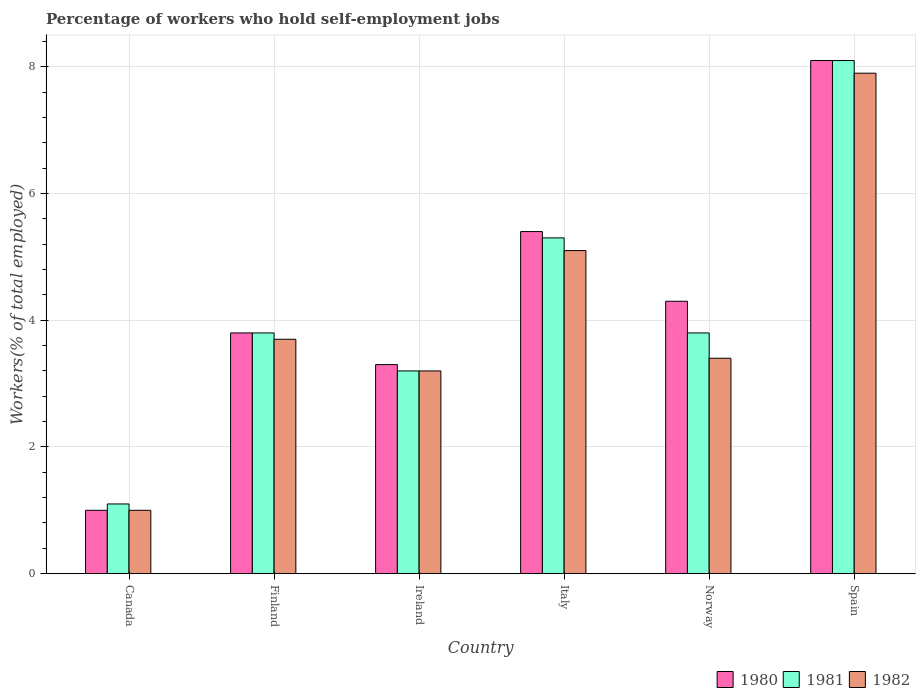How many different coloured bars are there?
Your answer should be compact. 3. Are the number of bars on each tick of the X-axis equal?
Your response must be concise. Yes. How many bars are there on the 2nd tick from the right?
Your answer should be compact. 3. What is the label of the 2nd group of bars from the left?
Your response must be concise. Finland. In how many cases, is the number of bars for a given country not equal to the number of legend labels?
Offer a terse response. 0. Across all countries, what is the maximum percentage of self-employed workers in 1982?
Ensure brevity in your answer.  7.9. Across all countries, what is the minimum percentage of self-employed workers in 1981?
Your answer should be compact. 1.1. In which country was the percentage of self-employed workers in 1980 maximum?
Make the answer very short. Spain. What is the total percentage of self-employed workers in 1982 in the graph?
Your answer should be compact. 24.3. What is the difference between the percentage of self-employed workers in 1981 in Canada and that in Spain?
Your answer should be very brief. -7. What is the difference between the percentage of self-employed workers in 1981 in Ireland and the percentage of self-employed workers in 1982 in Finland?
Your answer should be very brief. -0.5. What is the average percentage of self-employed workers in 1981 per country?
Your answer should be very brief. 4.22. What is the difference between the percentage of self-employed workers of/in 1981 and percentage of self-employed workers of/in 1980 in Ireland?
Keep it short and to the point. -0.1. In how many countries, is the percentage of self-employed workers in 1981 greater than 4 %?
Provide a succinct answer. 2. What is the ratio of the percentage of self-employed workers in 1980 in Italy to that in Spain?
Provide a succinct answer. 0.67. Is the percentage of self-employed workers in 1982 in Finland less than that in Norway?
Your answer should be very brief. No. What is the difference between the highest and the second highest percentage of self-employed workers in 1980?
Offer a terse response. 3.8. What is the difference between the highest and the lowest percentage of self-employed workers in 1982?
Provide a succinct answer. 6.9. In how many countries, is the percentage of self-employed workers in 1981 greater than the average percentage of self-employed workers in 1981 taken over all countries?
Ensure brevity in your answer.  2. What does the 1st bar from the right in Finland represents?
Provide a short and direct response. 1982. How many bars are there?
Give a very brief answer. 18. Are all the bars in the graph horizontal?
Provide a succinct answer. No. How many countries are there in the graph?
Your answer should be compact. 6. What is the difference between two consecutive major ticks on the Y-axis?
Your answer should be compact. 2. Does the graph contain any zero values?
Your answer should be compact. No. What is the title of the graph?
Offer a very short reply. Percentage of workers who hold self-employment jobs. Does "1995" appear as one of the legend labels in the graph?
Keep it short and to the point. No. What is the label or title of the Y-axis?
Provide a short and direct response. Workers(% of total employed). What is the Workers(% of total employed) in 1980 in Canada?
Ensure brevity in your answer.  1. What is the Workers(% of total employed) of 1981 in Canada?
Give a very brief answer. 1.1. What is the Workers(% of total employed) in 1980 in Finland?
Provide a short and direct response. 3.8. What is the Workers(% of total employed) in 1981 in Finland?
Give a very brief answer. 3.8. What is the Workers(% of total employed) in 1982 in Finland?
Your response must be concise. 3.7. What is the Workers(% of total employed) of 1980 in Ireland?
Ensure brevity in your answer.  3.3. What is the Workers(% of total employed) of 1981 in Ireland?
Provide a succinct answer. 3.2. What is the Workers(% of total employed) of 1982 in Ireland?
Provide a succinct answer. 3.2. What is the Workers(% of total employed) of 1980 in Italy?
Ensure brevity in your answer.  5.4. What is the Workers(% of total employed) of 1981 in Italy?
Your answer should be compact. 5.3. What is the Workers(% of total employed) in 1982 in Italy?
Provide a short and direct response. 5.1. What is the Workers(% of total employed) in 1980 in Norway?
Your response must be concise. 4.3. What is the Workers(% of total employed) in 1981 in Norway?
Make the answer very short. 3.8. What is the Workers(% of total employed) of 1982 in Norway?
Ensure brevity in your answer.  3.4. What is the Workers(% of total employed) of 1980 in Spain?
Provide a succinct answer. 8.1. What is the Workers(% of total employed) of 1981 in Spain?
Your answer should be compact. 8.1. What is the Workers(% of total employed) in 1982 in Spain?
Provide a succinct answer. 7.9. Across all countries, what is the maximum Workers(% of total employed) of 1980?
Provide a succinct answer. 8.1. Across all countries, what is the maximum Workers(% of total employed) in 1981?
Your answer should be very brief. 8.1. Across all countries, what is the maximum Workers(% of total employed) in 1982?
Provide a succinct answer. 7.9. Across all countries, what is the minimum Workers(% of total employed) of 1980?
Offer a very short reply. 1. Across all countries, what is the minimum Workers(% of total employed) of 1981?
Keep it short and to the point. 1.1. What is the total Workers(% of total employed) of 1980 in the graph?
Provide a short and direct response. 25.9. What is the total Workers(% of total employed) in 1981 in the graph?
Offer a terse response. 25.3. What is the total Workers(% of total employed) in 1982 in the graph?
Keep it short and to the point. 24.3. What is the difference between the Workers(% of total employed) in 1980 in Canada and that in Finland?
Make the answer very short. -2.8. What is the difference between the Workers(% of total employed) of 1982 in Canada and that in Finland?
Your answer should be compact. -2.7. What is the difference between the Workers(% of total employed) of 1980 in Canada and that in Ireland?
Offer a terse response. -2.3. What is the difference between the Workers(% of total employed) of 1981 in Canada and that in Ireland?
Your answer should be very brief. -2.1. What is the difference between the Workers(% of total employed) of 1982 in Canada and that in Ireland?
Ensure brevity in your answer.  -2.2. What is the difference between the Workers(% of total employed) of 1981 in Canada and that in Spain?
Make the answer very short. -7. What is the difference between the Workers(% of total employed) of 1982 in Canada and that in Spain?
Keep it short and to the point. -6.9. What is the difference between the Workers(% of total employed) in 1980 in Finland and that in Ireland?
Provide a succinct answer. 0.5. What is the difference between the Workers(% of total employed) in 1981 in Finland and that in Ireland?
Offer a terse response. 0.6. What is the difference between the Workers(% of total employed) in 1981 in Finland and that in Italy?
Make the answer very short. -1.5. What is the difference between the Workers(% of total employed) of 1982 in Finland and that in Italy?
Give a very brief answer. -1.4. What is the difference between the Workers(% of total employed) of 1981 in Finland and that in Norway?
Your answer should be compact. 0. What is the difference between the Workers(% of total employed) in 1980 in Finland and that in Spain?
Provide a succinct answer. -4.3. What is the difference between the Workers(% of total employed) of 1981 in Finland and that in Spain?
Provide a succinct answer. -4.3. What is the difference between the Workers(% of total employed) in 1980 in Ireland and that in Italy?
Give a very brief answer. -2.1. What is the difference between the Workers(% of total employed) of 1981 in Ireland and that in Norway?
Provide a short and direct response. -0.6. What is the difference between the Workers(% of total employed) of 1980 in Ireland and that in Spain?
Make the answer very short. -4.8. What is the difference between the Workers(% of total employed) in 1981 in Ireland and that in Spain?
Your answer should be very brief. -4.9. What is the difference between the Workers(% of total employed) of 1982 in Ireland and that in Spain?
Make the answer very short. -4.7. What is the difference between the Workers(% of total employed) in 1980 in Italy and that in Norway?
Your response must be concise. 1.1. What is the difference between the Workers(% of total employed) in 1981 in Italy and that in Norway?
Your answer should be very brief. 1.5. What is the difference between the Workers(% of total employed) in 1982 in Italy and that in Norway?
Provide a succinct answer. 1.7. What is the difference between the Workers(% of total employed) of 1980 in Italy and that in Spain?
Offer a terse response. -2.7. What is the difference between the Workers(% of total employed) in 1982 in Italy and that in Spain?
Make the answer very short. -2.8. What is the difference between the Workers(% of total employed) in 1982 in Norway and that in Spain?
Provide a short and direct response. -4.5. What is the difference between the Workers(% of total employed) of 1980 in Canada and the Workers(% of total employed) of 1982 in Finland?
Your answer should be very brief. -2.7. What is the difference between the Workers(% of total employed) in 1981 in Canada and the Workers(% of total employed) in 1982 in Finland?
Provide a succinct answer. -2.6. What is the difference between the Workers(% of total employed) of 1980 in Canada and the Workers(% of total employed) of 1982 in Ireland?
Make the answer very short. -2.2. What is the difference between the Workers(% of total employed) in 1980 in Canada and the Workers(% of total employed) in 1981 in Italy?
Make the answer very short. -4.3. What is the difference between the Workers(% of total employed) of 1981 in Canada and the Workers(% of total employed) of 1982 in Italy?
Your answer should be compact. -4. What is the difference between the Workers(% of total employed) in 1980 in Canada and the Workers(% of total employed) in 1981 in Norway?
Keep it short and to the point. -2.8. What is the difference between the Workers(% of total employed) of 1980 in Canada and the Workers(% of total employed) of 1981 in Spain?
Keep it short and to the point. -7.1. What is the difference between the Workers(% of total employed) of 1980 in Canada and the Workers(% of total employed) of 1982 in Spain?
Make the answer very short. -6.9. What is the difference between the Workers(% of total employed) in 1981 in Canada and the Workers(% of total employed) in 1982 in Spain?
Provide a succinct answer. -6.8. What is the difference between the Workers(% of total employed) in 1980 in Finland and the Workers(% of total employed) in 1981 in Ireland?
Keep it short and to the point. 0.6. What is the difference between the Workers(% of total employed) in 1981 in Finland and the Workers(% of total employed) in 1982 in Ireland?
Keep it short and to the point. 0.6. What is the difference between the Workers(% of total employed) of 1980 in Finland and the Workers(% of total employed) of 1981 in Italy?
Make the answer very short. -1.5. What is the difference between the Workers(% of total employed) in 1981 in Finland and the Workers(% of total employed) in 1982 in Italy?
Provide a short and direct response. -1.3. What is the difference between the Workers(% of total employed) in 1980 in Finland and the Workers(% of total employed) in 1981 in Norway?
Offer a very short reply. 0. What is the difference between the Workers(% of total employed) of 1980 in Finland and the Workers(% of total employed) of 1982 in Norway?
Your response must be concise. 0.4. What is the difference between the Workers(% of total employed) in 1981 in Finland and the Workers(% of total employed) in 1982 in Norway?
Your response must be concise. 0.4. What is the difference between the Workers(% of total employed) in 1981 in Finland and the Workers(% of total employed) in 1982 in Spain?
Offer a terse response. -4.1. What is the difference between the Workers(% of total employed) in 1980 in Ireland and the Workers(% of total employed) in 1981 in Italy?
Provide a succinct answer. -2. What is the difference between the Workers(% of total employed) of 1980 in Ireland and the Workers(% of total employed) of 1982 in Italy?
Provide a succinct answer. -1.8. What is the difference between the Workers(% of total employed) of 1981 in Ireland and the Workers(% of total employed) of 1982 in Italy?
Your answer should be compact. -1.9. What is the difference between the Workers(% of total employed) of 1980 in Ireland and the Workers(% of total employed) of 1981 in Norway?
Offer a very short reply. -0.5. What is the difference between the Workers(% of total employed) of 1980 in Ireland and the Workers(% of total employed) of 1981 in Spain?
Your response must be concise. -4.8. What is the difference between the Workers(% of total employed) of 1980 in Ireland and the Workers(% of total employed) of 1982 in Spain?
Your answer should be compact. -4.6. What is the difference between the Workers(% of total employed) of 1981 in Ireland and the Workers(% of total employed) of 1982 in Spain?
Offer a terse response. -4.7. What is the difference between the Workers(% of total employed) in 1981 in Italy and the Workers(% of total employed) in 1982 in Norway?
Your answer should be compact. 1.9. What is the difference between the Workers(% of total employed) of 1980 in Italy and the Workers(% of total employed) of 1982 in Spain?
Make the answer very short. -2.5. What is the difference between the Workers(% of total employed) of 1981 in Italy and the Workers(% of total employed) of 1982 in Spain?
Your response must be concise. -2.6. What is the difference between the Workers(% of total employed) of 1980 in Norway and the Workers(% of total employed) of 1982 in Spain?
Your answer should be compact. -3.6. What is the average Workers(% of total employed) of 1980 per country?
Offer a terse response. 4.32. What is the average Workers(% of total employed) of 1981 per country?
Provide a short and direct response. 4.22. What is the average Workers(% of total employed) of 1982 per country?
Offer a terse response. 4.05. What is the difference between the Workers(% of total employed) in 1980 and Workers(% of total employed) in 1981 in Canada?
Your answer should be very brief. -0.1. What is the difference between the Workers(% of total employed) in 1980 and Workers(% of total employed) in 1982 in Canada?
Your answer should be very brief. 0. What is the difference between the Workers(% of total employed) in 1981 and Workers(% of total employed) in 1982 in Canada?
Offer a terse response. 0.1. What is the difference between the Workers(% of total employed) of 1980 and Workers(% of total employed) of 1981 in Finland?
Offer a very short reply. 0. What is the difference between the Workers(% of total employed) of 1980 and Workers(% of total employed) of 1981 in Ireland?
Your answer should be compact. 0.1. What is the difference between the Workers(% of total employed) in 1981 and Workers(% of total employed) in 1982 in Ireland?
Your response must be concise. 0. What is the difference between the Workers(% of total employed) in 1980 and Workers(% of total employed) in 1981 in Italy?
Provide a succinct answer. 0.1. What is the difference between the Workers(% of total employed) of 1981 and Workers(% of total employed) of 1982 in Italy?
Your answer should be very brief. 0.2. What is the difference between the Workers(% of total employed) in 1980 and Workers(% of total employed) in 1981 in Norway?
Offer a terse response. 0.5. What is the difference between the Workers(% of total employed) in 1980 and Workers(% of total employed) in 1982 in Spain?
Make the answer very short. 0.2. What is the ratio of the Workers(% of total employed) of 1980 in Canada to that in Finland?
Make the answer very short. 0.26. What is the ratio of the Workers(% of total employed) of 1981 in Canada to that in Finland?
Your response must be concise. 0.29. What is the ratio of the Workers(% of total employed) in 1982 in Canada to that in Finland?
Keep it short and to the point. 0.27. What is the ratio of the Workers(% of total employed) in 1980 in Canada to that in Ireland?
Keep it short and to the point. 0.3. What is the ratio of the Workers(% of total employed) of 1981 in Canada to that in Ireland?
Give a very brief answer. 0.34. What is the ratio of the Workers(% of total employed) in 1982 in Canada to that in Ireland?
Offer a very short reply. 0.31. What is the ratio of the Workers(% of total employed) of 1980 in Canada to that in Italy?
Provide a succinct answer. 0.19. What is the ratio of the Workers(% of total employed) in 1981 in Canada to that in Italy?
Make the answer very short. 0.21. What is the ratio of the Workers(% of total employed) in 1982 in Canada to that in Italy?
Offer a terse response. 0.2. What is the ratio of the Workers(% of total employed) of 1980 in Canada to that in Norway?
Make the answer very short. 0.23. What is the ratio of the Workers(% of total employed) of 1981 in Canada to that in Norway?
Your answer should be compact. 0.29. What is the ratio of the Workers(% of total employed) of 1982 in Canada to that in Norway?
Your answer should be compact. 0.29. What is the ratio of the Workers(% of total employed) in 1980 in Canada to that in Spain?
Ensure brevity in your answer.  0.12. What is the ratio of the Workers(% of total employed) in 1981 in Canada to that in Spain?
Give a very brief answer. 0.14. What is the ratio of the Workers(% of total employed) of 1982 in Canada to that in Spain?
Provide a succinct answer. 0.13. What is the ratio of the Workers(% of total employed) of 1980 in Finland to that in Ireland?
Offer a very short reply. 1.15. What is the ratio of the Workers(% of total employed) in 1981 in Finland to that in Ireland?
Keep it short and to the point. 1.19. What is the ratio of the Workers(% of total employed) in 1982 in Finland to that in Ireland?
Make the answer very short. 1.16. What is the ratio of the Workers(% of total employed) in 1980 in Finland to that in Italy?
Your response must be concise. 0.7. What is the ratio of the Workers(% of total employed) in 1981 in Finland to that in Italy?
Your answer should be very brief. 0.72. What is the ratio of the Workers(% of total employed) of 1982 in Finland to that in Italy?
Your response must be concise. 0.73. What is the ratio of the Workers(% of total employed) of 1980 in Finland to that in Norway?
Keep it short and to the point. 0.88. What is the ratio of the Workers(% of total employed) of 1981 in Finland to that in Norway?
Your response must be concise. 1. What is the ratio of the Workers(% of total employed) in 1982 in Finland to that in Norway?
Your answer should be very brief. 1.09. What is the ratio of the Workers(% of total employed) of 1980 in Finland to that in Spain?
Keep it short and to the point. 0.47. What is the ratio of the Workers(% of total employed) in 1981 in Finland to that in Spain?
Offer a very short reply. 0.47. What is the ratio of the Workers(% of total employed) of 1982 in Finland to that in Spain?
Provide a succinct answer. 0.47. What is the ratio of the Workers(% of total employed) in 1980 in Ireland to that in Italy?
Make the answer very short. 0.61. What is the ratio of the Workers(% of total employed) in 1981 in Ireland to that in Italy?
Provide a short and direct response. 0.6. What is the ratio of the Workers(% of total employed) of 1982 in Ireland to that in Italy?
Your answer should be very brief. 0.63. What is the ratio of the Workers(% of total employed) in 1980 in Ireland to that in Norway?
Make the answer very short. 0.77. What is the ratio of the Workers(% of total employed) in 1981 in Ireland to that in Norway?
Provide a short and direct response. 0.84. What is the ratio of the Workers(% of total employed) in 1982 in Ireland to that in Norway?
Ensure brevity in your answer.  0.94. What is the ratio of the Workers(% of total employed) in 1980 in Ireland to that in Spain?
Provide a short and direct response. 0.41. What is the ratio of the Workers(% of total employed) of 1981 in Ireland to that in Spain?
Your response must be concise. 0.4. What is the ratio of the Workers(% of total employed) of 1982 in Ireland to that in Spain?
Your answer should be very brief. 0.41. What is the ratio of the Workers(% of total employed) of 1980 in Italy to that in Norway?
Provide a succinct answer. 1.26. What is the ratio of the Workers(% of total employed) of 1981 in Italy to that in Norway?
Keep it short and to the point. 1.39. What is the ratio of the Workers(% of total employed) in 1981 in Italy to that in Spain?
Provide a short and direct response. 0.65. What is the ratio of the Workers(% of total employed) of 1982 in Italy to that in Spain?
Ensure brevity in your answer.  0.65. What is the ratio of the Workers(% of total employed) of 1980 in Norway to that in Spain?
Give a very brief answer. 0.53. What is the ratio of the Workers(% of total employed) of 1981 in Norway to that in Spain?
Offer a terse response. 0.47. What is the ratio of the Workers(% of total employed) in 1982 in Norway to that in Spain?
Keep it short and to the point. 0.43. What is the difference between the highest and the second highest Workers(% of total employed) of 1981?
Provide a short and direct response. 2.8. What is the difference between the highest and the lowest Workers(% of total employed) of 1980?
Give a very brief answer. 7.1. What is the difference between the highest and the lowest Workers(% of total employed) in 1981?
Offer a very short reply. 7. 